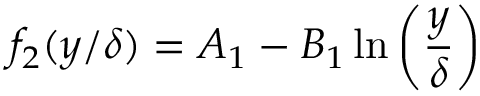<formula> <loc_0><loc_0><loc_500><loc_500>f _ { 2 } ( y / \delta ) = A _ { 1 } - B _ { 1 } \ln \left ( \frac { y } { \delta } \right )</formula> 